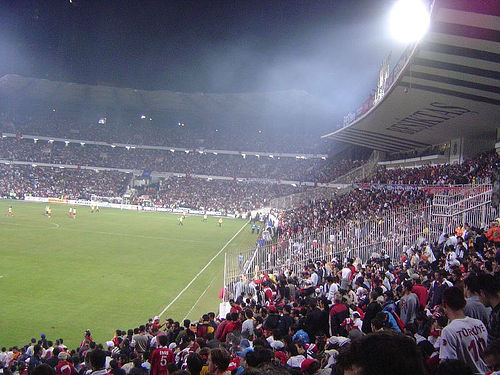<image>
Is there a light next to the field? No. The light is not positioned next to the field. They are located in different areas of the scene. 